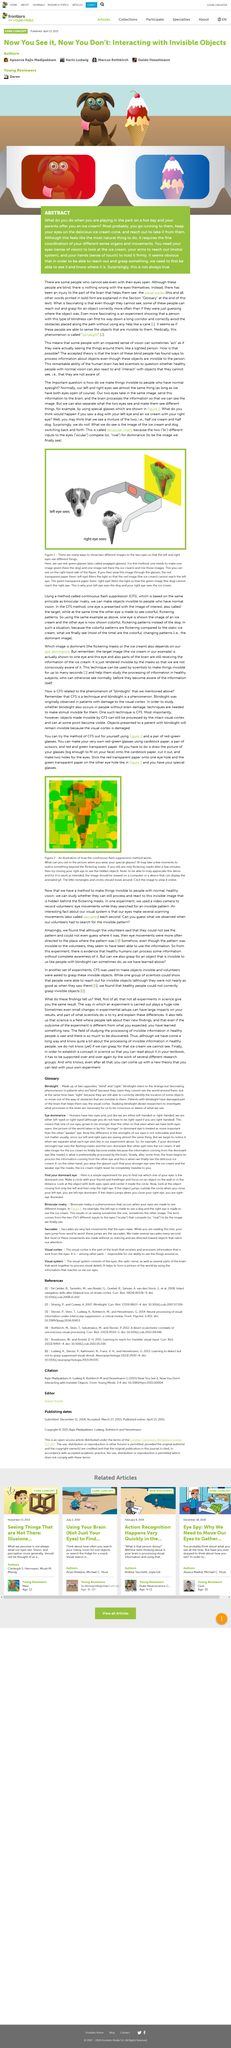Indicate a few pertinent items in this graphic. I have determined that your arms are part of the motor system, which are responsible for movement and function in your body. The eyes are the sense of vision, and they are the means by which we perceive and interpret visual information. Ice cream is used as an example in the text. 